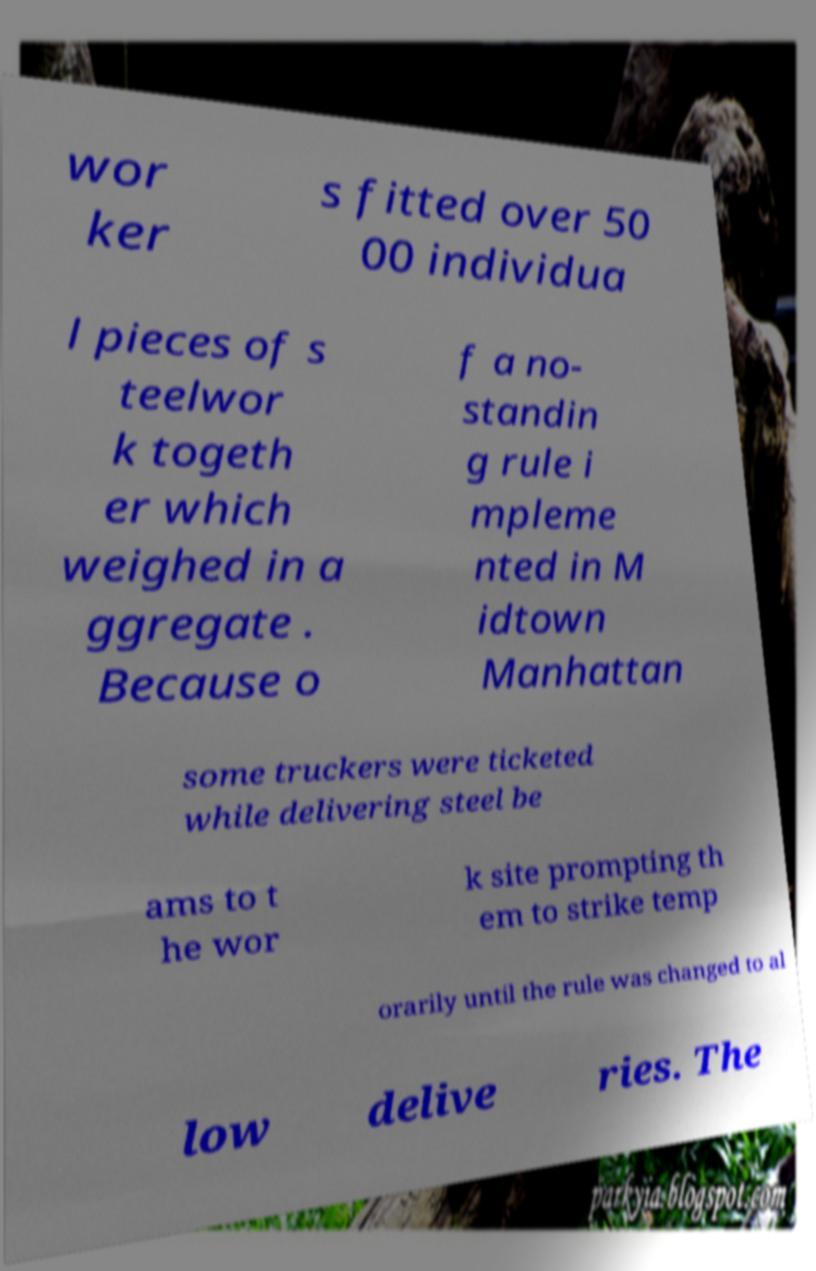Can you accurately transcribe the text from the provided image for me? wor ker s fitted over 50 00 individua l pieces of s teelwor k togeth er which weighed in a ggregate . Because o f a no- standin g rule i mpleme nted in M idtown Manhattan some truckers were ticketed while delivering steel be ams to t he wor k site prompting th em to strike temp orarily until the rule was changed to al low delive ries. The 